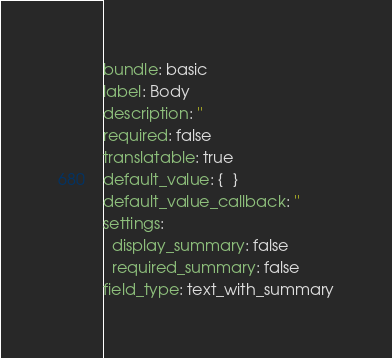Convert code to text. <code><loc_0><loc_0><loc_500><loc_500><_YAML_>bundle: basic
label: Body
description: ''
required: false
translatable: true
default_value: {  }
default_value_callback: ''
settings:
  display_summary: false
  required_summary: false
field_type: text_with_summary
</code> 